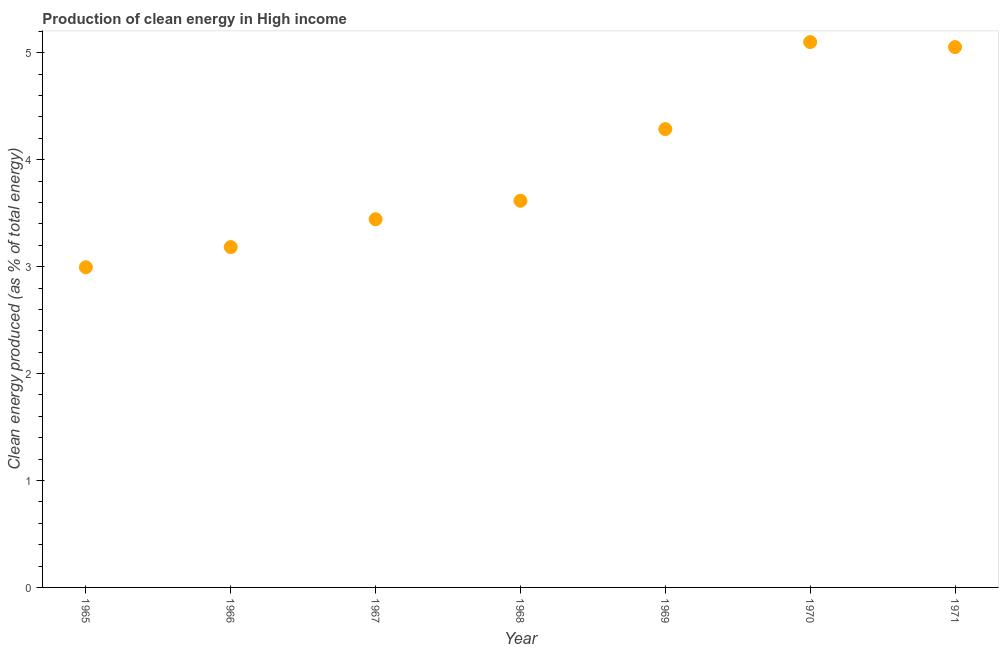What is the production of clean energy in 1966?
Ensure brevity in your answer.  3.18. Across all years, what is the maximum production of clean energy?
Your answer should be compact. 5.1. Across all years, what is the minimum production of clean energy?
Make the answer very short. 2.99. In which year was the production of clean energy maximum?
Your answer should be very brief. 1970. In which year was the production of clean energy minimum?
Your answer should be very brief. 1965. What is the sum of the production of clean energy?
Your answer should be compact. 27.68. What is the difference between the production of clean energy in 1965 and 1970?
Keep it short and to the point. -2.11. What is the average production of clean energy per year?
Make the answer very short. 3.95. What is the median production of clean energy?
Give a very brief answer. 3.62. In how many years, is the production of clean energy greater than 4 %?
Your answer should be compact. 3. Do a majority of the years between 1970 and 1968 (inclusive) have production of clean energy greater than 4.6 %?
Your response must be concise. No. What is the ratio of the production of clean energy in 1967 to that in 1970?
Your answer should be very brief. 0.68. Is the production of clean energy in 1969 less than that in 1970?
Keep it short and to the point. Yes. What is the difference between the highest and the second highest production of clean energy?
Provide a succinct answer. 0.05. Is the sum of the production of clean energy in 1966 and 1969 greater than the maximum production of clean energy across all years?
Keep it short and to the point. Yes. What is the difference between the highest and the lowest production of clean energy?
Your answer should be compact. 2.11. Does the production of clean energy monotonically increase over the years?
Offer a terse response. No. How many dotlines are there?
Ensure brevity in your answer.  1. How many years are there in the graph?
Your response must be concise. 7. What is the difference between two consecutive major ticks on the Y-axis?
Keep it short and to the point. 1. Does the graph contain grids?
Provide a succinct answer. No. What is the title of the graph?
Offer a very short reply. Production of clean energy in High income. What is the label or title of the Y-axis?
Your answer should be very brief. Clean energy produced (as % of total energy). What is the Clean energy produced (as % of total energy) in 1965?
Keep it short and to the point. 2.99. What is the Clean energy produced (as % of total energy) in 1966?
Your response must be concise. 3.18. What is the Clean energy produced (as % of total energy) in 1967?
Offer a very short reply. 3.44. What is the Clean energy produced (as % of total energy) in 1968?
Provide a succinct answer. 3.62. What is the Clean energy produced (as % of total energy) in 1969?
Your answer should be very brief. 4.29. What is the Clean energy produced (as % of total energy) in 1970?
Give a very brief answer. 5.1. What is the Clean energy produced (as % of total energy) in 1971?
Provide a succinct answer. 5.05. What is the difference between the Clean energy produced (as % of total energy) in 1965 and 1966?
Keep it short and to the point. -0.19. What is the difference between the Clean energy produced (as % of total energy) in 1965 and 1967?
Ensure brevity in your answer.  -0.45. What is the difference between the Clean energy produced (as % of total energy) in 1965 and 1968?
Provide a short and direct response. -0.62. What is the difference between the Clean energy produced (as % of total energy) in 1965 and 1969?
Offer a very short reply. -1.29. What is the difference between the Clean energy produced (as % of total energy) in 1965 and 1970?
Provide a short and direct response. -2.11. What is the difference between the Clean energy produced (as % of total energy) in 1965 and 1971?
Offer a very short reply. -2.06. What is the difference between the Clean energy produced (as % of total energy) in 1966 and 1967?
Your answer should be compact. -0.26. What is the difference between the Clean energy produced (as % of total energy) in 1966 and 1968?
Your response must be concise. -0.43. What is the difference between the Clean energy produced (as % of total energy) in 1966 and 1969?
Offer a very short reply. -1.1. What is the difference between the Clean energy produced (as % of total energy) in 1966 and 1970?
Offer a very short reply. -1.92. What is the difference between the Clean energy produced (as % of total energy) in 1966 and 1971?
Your response must be concise. -1.87. What is the difference between the Clean energy produced (as % of total energy) in 1967 and 1968?
Provide a succinct answer. -0.17. What is the difference between the Clean energy produced (as % of total energy) in 1967 and 1969?
Keep it short and to the point. -0.84. What is the difference between the Clean energy produced (as % of total energy) in 1967 and 1970?
Your response must be concise. -1.66. What is the difference between the Clean energy produced (as % of total energy) in 1967 and 1971?
Keep it short and to the point. -1.61. What is the difference between the Clean energy produced (as % of total energy) in 1968 and 1969?
Make the answer very short. -0.67. What is the difference between the Clean energy produced (as % of total energy) in 1968 and 1970?
Your answer should be compact. -1.48. What is the difference between the Clean energy produced (as % of total energy) in 1968 and 1971?
Offer a very short reply. -1.44. What is the difference between the Clean energy produced (as % of total energy) in 1969 and 1970?
Give a very brief answer. -0.81. What is the difference between the Clean energy produced (as % of total energy) in 1969 and 1971?
Make the answer very short. -0.77. What is the difference between the Clean energy produced (as % of total energy) in 1970 and 1971?
Ensure brevity in your answer.  0.05. What is the ratio of the Clean energy produced (as % of total energy) in 1965 to that in 1966?
Ensure brevity in your answer.  0.94. What is the ratio of the Clean energy produced (as % of total energy) in 1965 to that in 1967?
Offer a terse response. 0.87. What is the ratio of the Clean energy produced (as % of total energy) in 1965 to that in 1968?
Give a very brief answer. 0.83. What is the ratio of the Clean energy produced (as % of total energy) in 1965 to that in 1969?
Offer a terse response. 0.7. What is the ratio of the Clean energy produced (as % of total energy) in 1965 to that in 1970?
Provide a short and direct response. 0.59. What is the ratio of the Clean energy produced (as % of total energy) in 1965 to that in 1971?
Offer a very short reply. 0.59. What is the ratio of the Clean energy produced (as % of total energy) in 1966 to that in 1967?
Your answer should be compact. 0.92. What is the ratio of the Clean energy produced (as % of total energy) in 1966 to that in 1968?
Offer a very short reply. 0.88. What is the ratio of the Clean energy produced (as % of total energy) in 1966 to that in 1969?
Make the answer very short. 0.74. What is the ratio of the Clean energy produced (as % of total energy) in 1966 to that in 1970?
Make the answer very short. 0.62. What is the ratio of the Clean energy produced (as % of total energy) in 1966 to that in 1971?
Keep it short and to the point. 0.63. What is the ratio of the Clean energy produced (as % of total energy) in 1967 to that in 1969?
Your response must be concise. 0.8. What is the ratio of the Clean energy produced (as % of total energy) in 1967 to that in 1970?
Provide a succinct answer. 0.68. What is the ratio of the Clean energy produced (as % of total energy) in 1967 to that in 1971?
Offer a terse response. 0.68. What is the ratio of the Clean energy produced (as % of total energy) in 1968 to that in 1969?
Ensure brevity in your answer.  0.84. What is the ratio of the Clean energy produced (as % of total energy) in 1968 to that in 1970?
Make the answer very short. 0.71. What is the ratio of the Clean energy produced (as % of total energy) in 1968 to that in 1971?
Make the answer very short. 0.72. What is the ratio of the Clean energy produced (as % of total energy) in 1969 to that in 1970?
Ensure brevity in your answer.  0.84. What is the ratio of the Clean energy produced (as % of total energy) in 1969 to that in 1971?
Give a very brief answer. 0.85. What is the ratio of the Clean energy produced (as % of total energy) in 1970 to that in 1971?
Your answer should be compact. 1.01. 